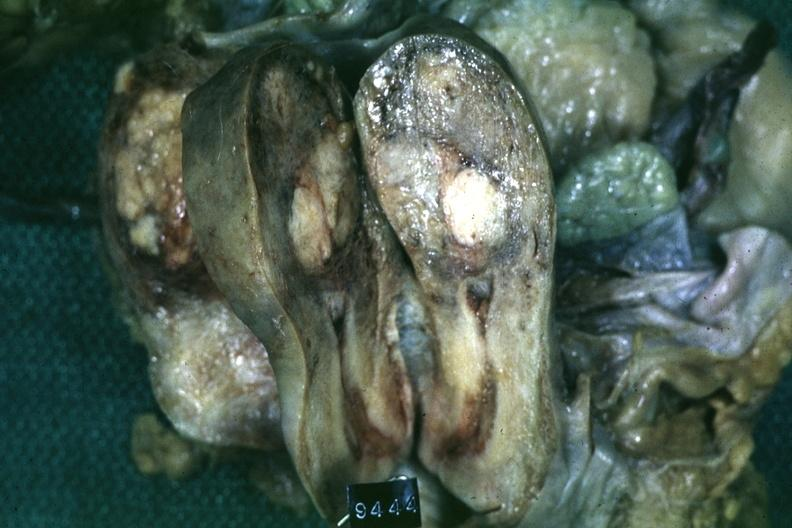what is present?
Answer the question using a single word or phrase. Uterus 